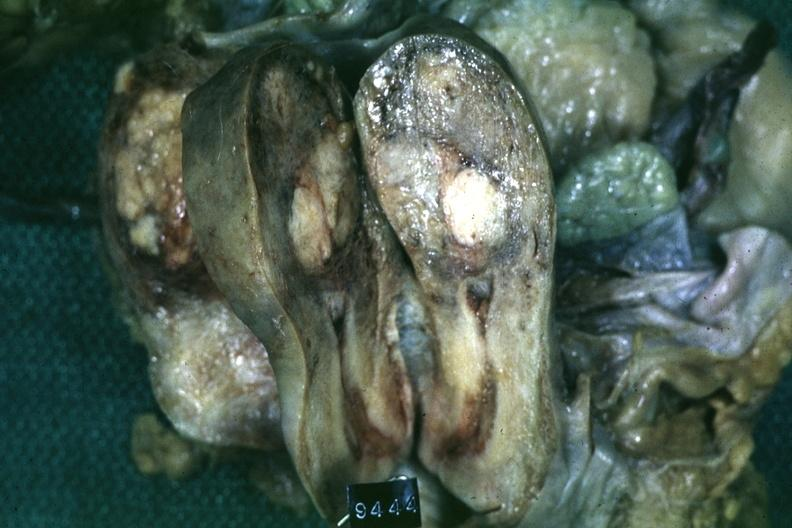what is present?
Answer the question using a single word or phrase. Uterus 